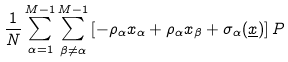Convert formula to latex. <formula><loc_0><loc_0><loc_500><loc_500>\frac { 1 } { N } \sum ^ { M - 1 } _ { \alpha = 1 } \sum ^ { M - 1 } _ { \beta \neq \alpha } \left [ - \rho _ { \alpha } x _ { \alpha } + \rho _ { \alpha } x _ { \beta } + \sigma _ { \alpha } ( \underline { x } ) \right ] P</formula> 